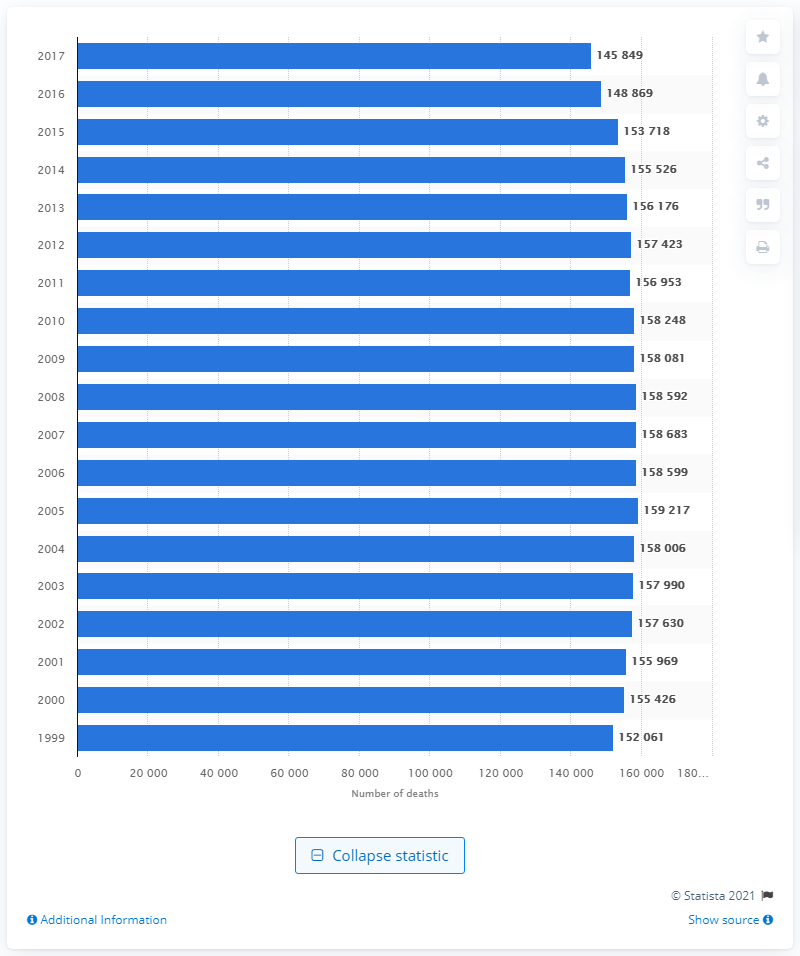In what year was the highest number of deaths due to lung and bronchus cancer reported?
 2005 